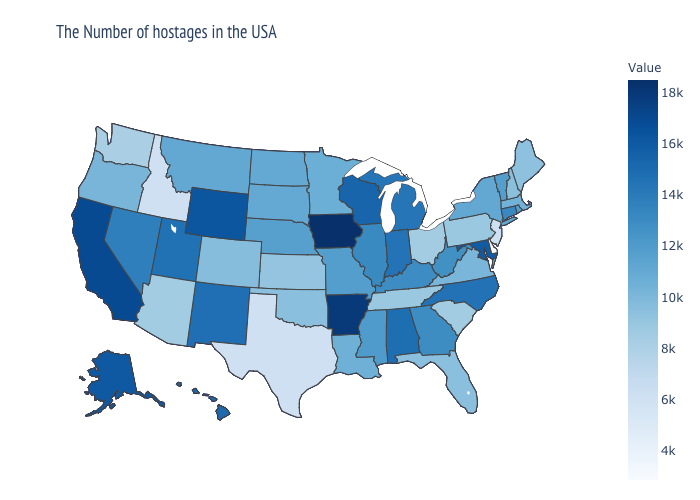Does Arizona have a higher value than Idaho?
Be succinct. Yes. 